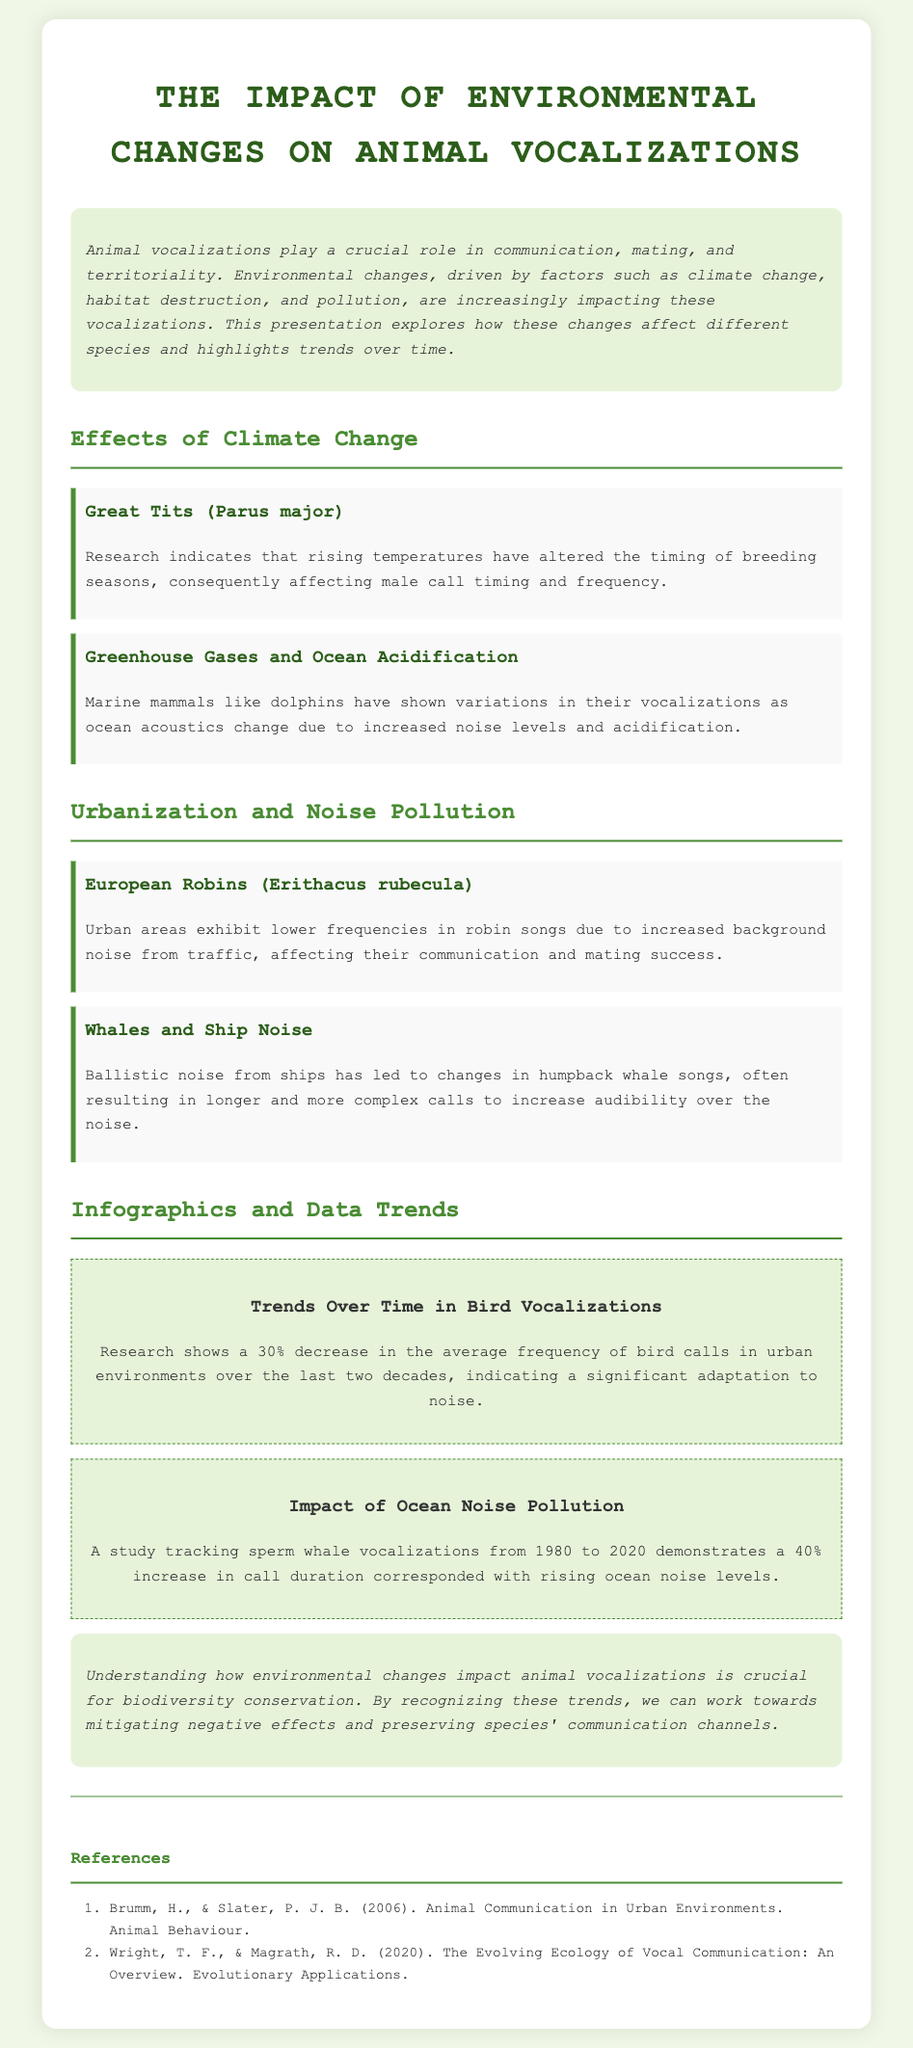what is the title of the presentation? The title of the presentation is explicitly mentioned at the beginning of the document.
Answer: The Impact of Environmental Changes on Animal Vocalizations which species is affected by rising temperatures according to the document? The document provides an example of a specific species affected by rising temperatures.
Answer: Great Tits (Parus major) what percentage decrease in bird vocalization frequency is reported in urban environments? The document includes a statistic about changes in bird vocalizations in urban settings based on research.
Answer: 30% how does urbanization affect European Robin songs as mentioned in the document? The document describes the impact of urban noise on European Robin songs specifically.
Answer: Lower frequencies what is the main conclusion regarding environmental changes and animal vocalizations? The conclusion summarizes the importance of understanding the relationship between environmental changes and vocalizations.
Answer: Crucial for biodiversity conservation 